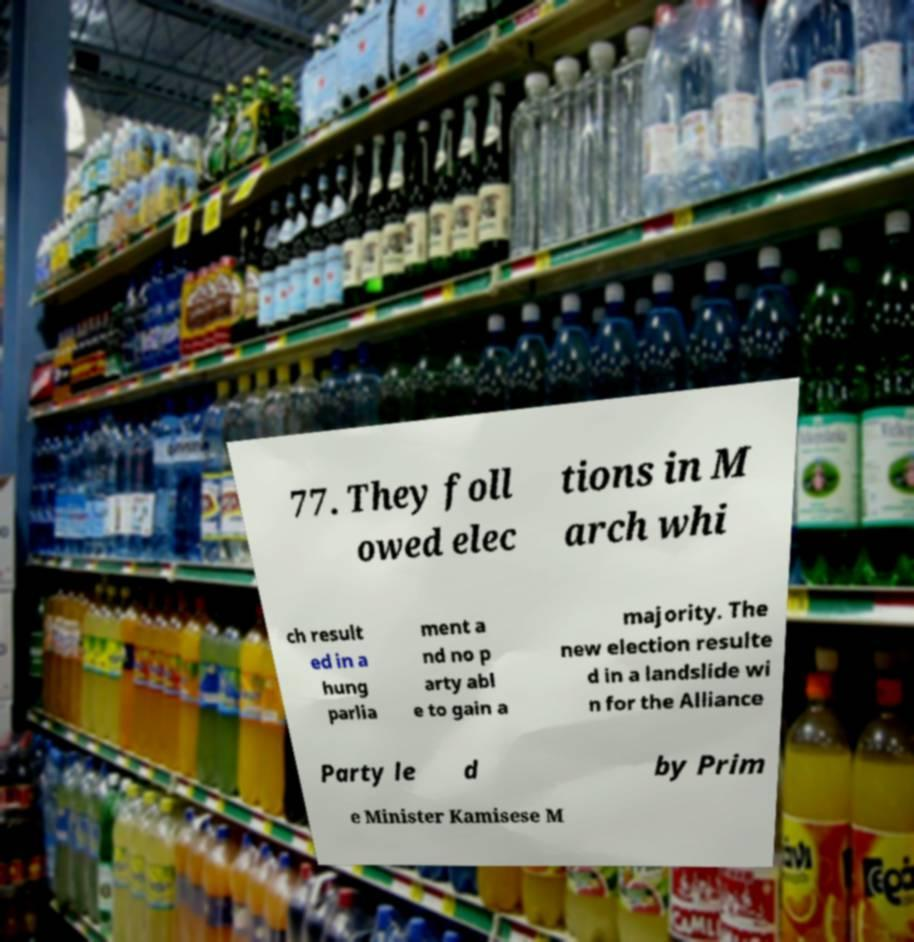Please identify and transcribe the text found in this image. 77. They foll owed elec tions in M arch whi ch result ed in a hung parlia ment a nd no p arty abl e to gain a majority. The new election resulte d in a landslide wi n for the Alliance Party le d by Prim e Minister Kamisese M 